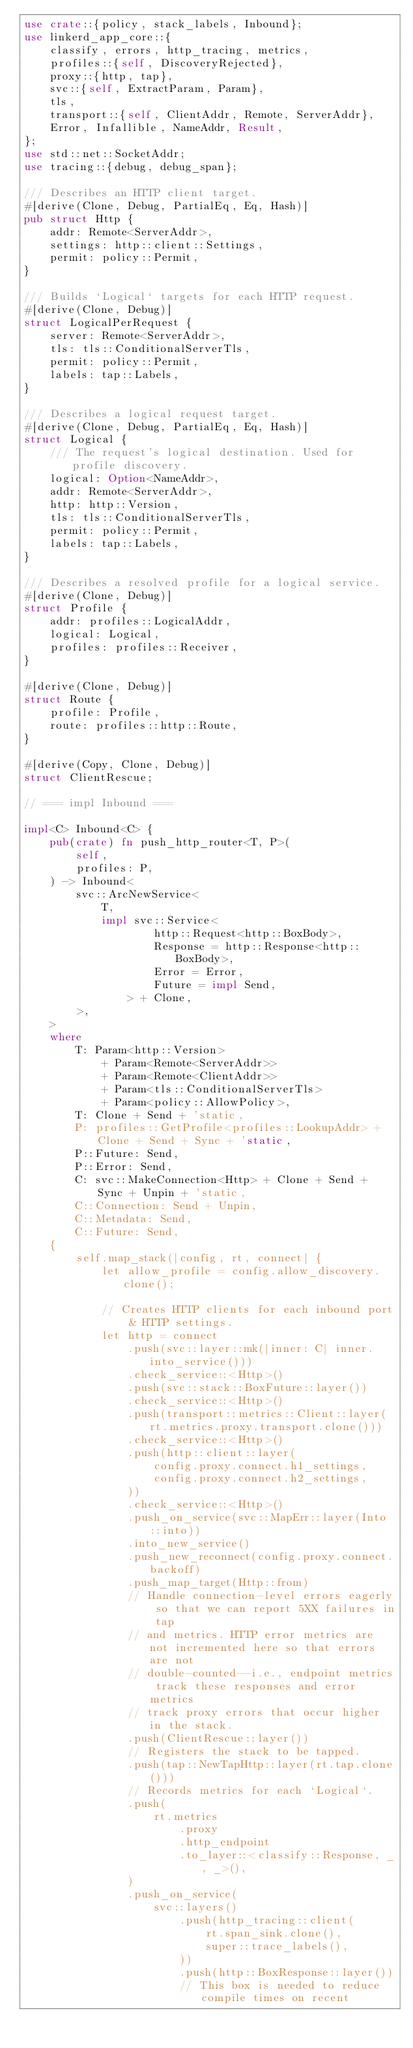<code> <loc_0><loc_0><loc_500><loc_500><_Rust_>use crate::{policy, stack_labels, Inbound};
use linkerd_app_core::{
    classify, errors, http_tracing, metrics,
    profiles::{self, DiscoveryRejected},
    proxy::{http, tap},
    svc::{self, ExtractParam, Param},
    tls,
    transport::{self, ClientAddr, Remote, ServerAddr},
    Error, Infallible, NameAddr, Result,
};
use std::net::SocketAddr;
use tracing::{debug, debug_span};

/// Describes an HTTP client target.
#[derive(Clone, Debug, PartialEq, Eq, Hash)]
pub struct Http {
    addr: Remote<ServerAddr>,
    settings: http::client::Settings,
    permit: policy::Permit,
}

/// Builds `Logical` targets for each HTTP request.
#[derive(Clone, Debug)]
struct LogicalPerRequest {
    server: Remote<ServerAddr>,
    tls: tls::ConditionalServerTls,
    permit: policy::Permit,
    labels: tap::Labels,
}

/// Describes a logical request target.
#[derive(Clone, Debug, PartialEq, Eq, Hash)]
struct Logical {
    /// The request's logical destination. Used for profile discovery.
    logical: Option<NameAddr>,
    addr: Remote<ServerAddr>,
    http: http::Version,
    tls: tls::ConditionalServerTls,
    permit: policy::Permit,
    labels: tap::Labels,
}

/// Describes a resolved profile for a logical service.
#[derive(Clone, Debug)]
struct Profile {
    addr: profiles::LogicalAddr,
    logical: Logical,
    profiles: profiles::Receiver,
}

#[derive(Clone, Debug)]
struct Route {
    profile: Profile,
    route: profiles::http::Route,
}

#[derive(Copy, Clone, Debug)]
struct ClientRescue;

// === impl Inbound ===

impl<C> Inbound<C> {
    pub(crate) fn push_http_router<T, P>(
        self,
        profiles: P,
    ) -> Inbound<
        svc::ArcNewService<
            T,
            impl svc::Service<
                    http::Request<http::BoxBody>,
                    Response = http::Response<http::BoxBody>,
                    Error = Error,
                    Future = impl Send,
                > + Clone,
        >,
    >
    where
        T: Param<http::Version>
            + Param<Remote<ServerAddr>>
            + Param<Remote<ClientAddr>>
            + Param<tls::ConditionalServerTls>
            + Param<policy::AllowPolicy>,
        T: Clone + Send + 'static,
        P: profiles::GetProfile<profiles::LookupAddr> + Clone + Send + Sync + 'static,
        P::Future: Send,
        P::Error: Send,
        C: svc::MakeConnection<Http> + Clone + Send + Sync + Unpin + 'static,
        C::Connection: Send + Unpin,
        C::Metadata: Send,
        C::Future: Send,
    {
        self.map_stack(|config, rt, connect| {
            let allow_profile = config.allow_discovery.clone();

            // Creates HTTP clients for each inbound port & HTTP settings.
            let http = connect
                .push(svc::layer::mk(|inner: C| inner.into_service()))
                .check_service::<Http>()
                .push(svc::stack::BoxFuture::layer())
                .check_service::<Http>()
                .push(transport::metrics::Client::layer(rt.metrics.proxy.transport.clone()))
                .check_service::<Http>()
                .push(http::client::layer(
                    config.proxy.connect.h1_settings,
                    config.proxy.connect.h2_settings,
                ))
                .check_service::<Http>()
                .push_on_service(svc::MapErr::layer(Into::into))
                .into_new_service()
                .push_new_reconnect(config.proxy.connect.backoff)
                .push_map_target(Http::from)
                // Handle connection-level errors eagerly so that we can report 5XX failures in tap
                // and metrics. HTTP error metrics are not incremented here so that errors are not
                // double-counted--i.e., endpoint metrics track these responses and error metrics
                // track proxy errors that occur higher in the stack.
                .push(ClientRescue::layer())
                // Registers the stack to be tapped.
                .push(tap::NewTapHttp::layer(rt.tap.clone()))
                // Records metrics for each `Logical`.
                .push(
                    rt.metrics
                        .proxy
                        .http_endpoint
                        .to_layer::<classify::Response, _, _>(),
                )
                .push_on_service(
                    svc::layers()
                        .push(http_tracing::client(
                            rt.span_sink.clone(),
                            super::trace_labels(),
                        ))
                        .push(http::BoxResponse::layer())
                        // This box is needed to reduce compile times on recent</code> 